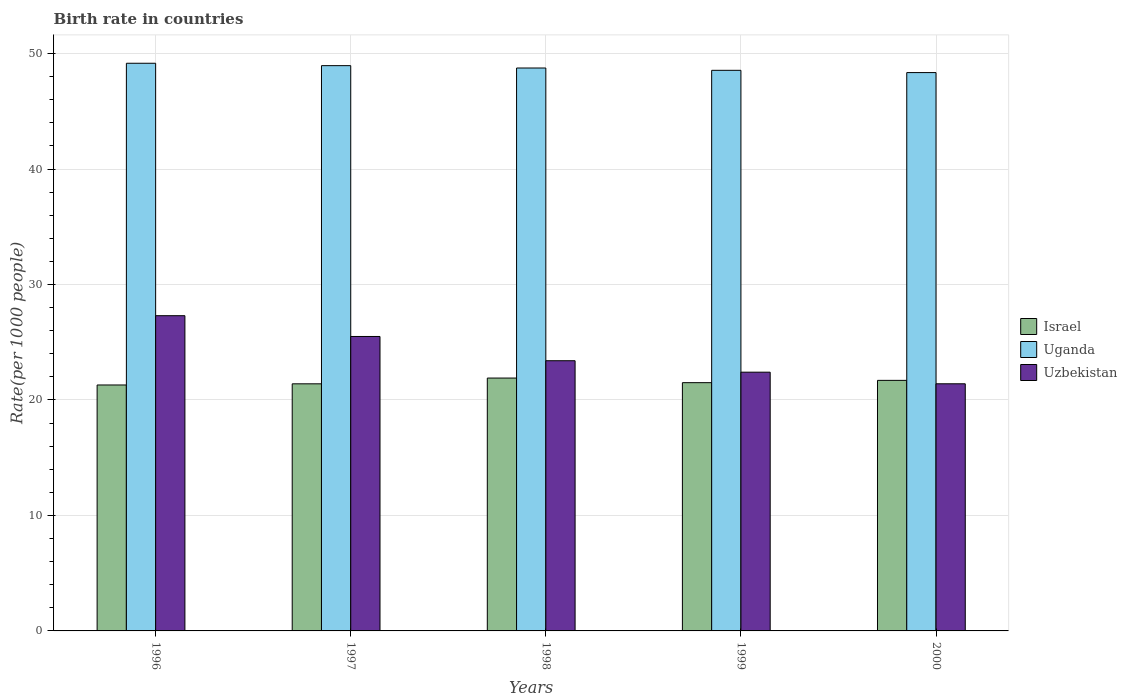How many groups of bars are there?
Provide a succinct answer. 5. Are the number of bars per tick equal to the number of legend labels?
Give a very brief answer. Yes. In how many cases, is the number of bars for a given year not equal to the number of legend labels?
Keep it short and to the point. 0. What is the birth rate in Uganda in 1998?
Keep it short and to the point. 48.75. Across all years, what is the maximum birth rate in Uzbekistan?
Make the answer very short. 27.3. Across all years, what is the minimum birth rate in Uganda?
Keep it short and to the point. 48.35. In which year was the birth rate in Israel minimum?
Make the answer very short. 1996. What is the total birth rate in Uganda in the graph?
Give a very brief answer. 243.78. What is the difference between the birth rate in Uzbekistan in 1997 and that in 2000?
Your answer should be compact. 4.1. What is the difference between the birth rate in Israel in 2000 and the birth rate in Uganda in 1997?
Make the answer very short. -27.26. What is the average birth rate in Uganda per year?
Give a very brief answer. 48.76. In the year 1997, what is the difference between the birth rate in Uganda and birth rate in Israel?
Keep it short and to the point. 27.56. In how many years, is the birth rate in Uganda greater than 12?
Offer a very short reply. 5. What is the ratio of the birth rate in Uganda in 1996 to that in 1997?
Give a very brief answer. 1. Is the birth rate in Uganda in 1998 less than that in 2000?
Give a very brief answer. No. Is the difference between the birth rate in Uganda in 1996 and 1998 greater than the difference between the birth rate in Israel in 1996 and 1998?
Offer a very short reply. Yes. What is the difference between the highest and the second highest birth rate in Israel?
Make the answer very short. 0.2. What is the difference between the highest and the lowest birth rate in Uganda?
Keep it short and to the point. 0.81. What does the 3rd bar from the left in 1996 represents?
Provide a succinct answer. Uzbekistan. What does the 1st bar from the right in 1996 represents?
Your response must be concise. Uzbekistan. Is it the case that in every year, the sum of the birth rate in Israel and birth rate in Uganda is greater than the birth rate in Uzbekistan?
Offer a very short reply. Yes. How many years are there in the graph?
Keep it short and to the point. 5. Does the graph contain any zero values?
Ensure brevity in your answer.  No. Does the graph contain grids?
Your answer should be compact. Yes. How are the legend labels stacked?
Keep it short and to the point. Vertical. What is the title of the graph?
Provide a short and direct response. Birth rate in countries. Does "Italy" appear as one of the legend labels in the graph?
Ensure brevity in your answer.  No. What is the label or title of the X-axis?
Make the answer very short. Years. What is the label or title of the Y-axis?
Your answer should be compact. Rate(per 1000 people). What is the Rate(per 1000 people) of Israel in 1996?
Offer a very short reply. 21.3. What is the Rate(per 1000 people) in Uganda in 1996?
Your response must be concise. 49.16. What is the Rate(per 1000 people) of Uzbekistan in 1996?
Offer a very short reply. 27.3. What is the Rate(per 1000 people) in Israel in 1997?
Give a very brief answer. 21.4. What is the Rate(per 1000 people) in Uganda in 1997?
Ensure brevity in your answer.  48.96. What is the Rate(per 1000 people) in Uzbekistan in 1997?
Provide a short and direct response. 25.5. What is the Rate(per 1000 people) of Israel in 1998?
Provide a succinct answer. 21.9. What is the Rate(per 1000 people) in Uganda in 1998?
Give a very brief answer. 48.75. What is the Rate(per 1000 people) in Uzbekistan in 1998?
Give a very brief answer. 23.4. What is the Rate(per 1000 people) of Israel in 1999?
Offer a terse response. 21.5. What is the Rate(per 1000 people) of Uganda in 1999?
Your answer should be compact. 48.55. What is the Rate(per 1000 people) of Uzbekistan in 1999?
Offer a terse response. 22.41. What is the Rate(per 1000 people) in Israel in 2000?
Offer a terse response. 21.7. What is the Rate(per 1000 people) in Uganda in 2000?
Your response must be concise. 48.35. What is the Rate(per 1000 people) in Uzbekistan in 2000?
Keep it short and to the point. 21.4. Across all years, what is the maximum Rate(per 1000 people) of Israel?
Keep it short and to the point. 21.9. Across all years, what is the maximum Rate(per 1000 people) of Uganda?
Give a very brief answer. 49.16. Across all years, what is the maximum Rate(per 1000 people) in Uzbekistan?
Ensure brevity in your answer.  27.3. Across all years, what is the minimum Rate(per 1000 people) of Israel?
Provide a short and direct response. 21.3. Across all years, what is the minimum Rate(per 1000 people) in Uganda?
Your answer should be compact. 48.35. Across all years, what is the minimum Rate(per 1000 people) in Uzbekistan?
Offer a terse response. 21.4. What is the total Rate(per 1000 people) of Israel in the graph?
Offer a very short reply. 107.8. What is the total Rate(per 1000 people) in Uganda in the graph?
Offer a terse response. 243.78. What is the total Rate(per 1000 people) of Uzbekistan in the graph?
Your response must be concise. 120.01. What is the difference between the Rate(per 1000 people) of Israel in 1996 and that in 1997?
Provide a succinct answer. -0.1. What is the difference between the Rate(per 1000 people) of Uganda in 1996 and that in 1997?
Make the answer very short. 0.21. What is the difference between the Rate(per 1000 people) in Uganda in 1996 and that in 1998?
Make the answer very short. 0.41. What is the difference between the Rate(per 1000 people) of Uzbekistan in 1996 and that in 1998?
Your answer should be compact. 3.9. What is the difference between the Rate(per 1000 people) of Uganda in 1996 and that in 1999?
Give a very brief answer. 0.61. What is the difference between the Rate(per 1000 people) in Uzbekistan in 1996 and that in 1999?
Keep it short and to the point. 4.89. What is the difference between the Rate(per 1000 people) in Israel in 1996 and that in 2000?
Make the answer very short. -0.4. What is the difference between the Rate(per 1000 people) of Uganda in 1996 and that in 2000?
Offer a very short reply. 0.81. What is the difference between the Rate(per 1000 people) of Uzbekistan in 1996 and that in 2000?
Keep it short and to the point. 5.9. What is the difference between the Rate(per 1000 people) in Israel in 1997 and that in 1998?
Keep it short and to the point. -0.5. What is the difference between the Rate(per 1000 people) in Uganda in 1997 and that in 1998?
Give a very brief answer. 0.2. What is the difference between the Rate(per 1000 people) in Israel in 1997 and that in 1999?
Provide a succinct answer. -0.1. What is the difference between the Rate(per 1000 people) in Uganda in 1997 and that in 1999?
Provide a succinct answer. 0.4. What is the difference between the Rate(per 1000 people) in Uzbekistan in 1997 and that in 1999?
Make the answer very short. 3.09. What is the difference between the Rate(per 1000 people) in Uganda in 1997 and that in 2000?
Give a very brief answer. 0.6. What is the difference between the Rate(per 1000 people) in Uzbekistan in 1997 and that in 2000?
Give a very brief answer. 4.1. What is the difference between the Rate(per 1000 people) in Israel in 1998 and that in 1999?
Your answer should be very brief. 0.4. What is the difference between the Rate(per 1000 people) in Uganda in 1998 and that in 1999?
Give a very brief answer. 0.2. What is the difference between the Rate(per 1000 people) of Israel in 1998 and that in 2000?
Offer a terse response. 0.2. What is the difference between the Rate(per 1000 people) in Uganda in 1998 and that in 2000?
Your answer should be very brief. 0.4. What is the difference between the Rate(per 1000 people) in Uzbekistan in 1998 and that in 2000?
Your answer should be very brief. 2. What is the difference between the Rate(per 1000 people) of Uganda in 1999 and that in 2000?
Your answer should be compact. 0.2. What is the difference between the Rate(per 1000 people) of Israel in 1996 and the Rate(per 1000 people) of Uganda in 1997?
Provide a short and direct response. -27.66. What is the difference between the Rate(per 1000 people) in Uganda in 1996 and the Rate(per 1000 people) in Uzbekistan in 1997?
Keep it short and to the point. 23.66. What is the difference between the Rate(per 1000 people) in Israel in 1996 and the Rate(per 1000 people) in Uganda in 1998?
Provide a succinct answer. -27.45. What is the difference between the Rate(per 1000 people) of Israel in 1996 and the Rate(per 1000 people) of Uzbekistan in 1998?
Your answer should be very brief. -2.1. What is the difference between the Rate(per 1000 people) in Uganda in 1996 and the Rate(per 1000 people) in Uzbekistan in 1998?
Make the answer very short. 25.76. What is the difference between the Rate(per 1000 people) of Israel in 1996 and the Rate(per 1000 people) of Uganda in 1999?
Offer a terse response. -27.25. What is the difference between the Rate(per 1000 people) in Israel in 1996 and the Rate(per 1000 people) in Uzbekistan in 1999?
Keep it short and to the point. -1.11. What is the difference between the Rate(per 1000 people) of Uganda in 1996 and the Rate(per 1000 people) of Uzbekistan in 1999?
Offer a terse response. 26.75. What is the difference between the Rate(per 1000 people) of Israel in 1996 and the Rate(per 1000 people) of Uganda in 2000?
Your answer should be very brief. -27.05. What is the difference between the Rate(per 1000 people) of Israel in 1996 and the Rate(per 1000 people) of Uzbekistan in 2000?
Your answer should be very brief. -0.1. What is the difference between the Rate(per 1000 people) of Uganda in 1996 and the Rate(per 1000 people) of Uzbekistan in 2000?
Provide a short and direct response. 27.76. What is the difference between the Rate(per 1000 people) of Israel in 1997 and the Rate(per 1000 people) of Uganda in 1998?
Your answer should be compact. -27.35. What is the difference between the Rate(per 1000 people) in Israel in 1997 and the Rate(per 1000 people) in Uzbekistan in 1998?
Give a very brief answer. -2. What is the difference between the Rate(per 1000 people) in Uganda in 1997 and the Rate(per 1000 people) in Uzbekistan in 1998?
Give a very brief answer. 25.56. What is the difference between the Rate(per 1000 people) in Israel in 1997 and the Rate(per 1000 people) in Uganda in 1999?
Make the answer very short. -27.15. What is the difference between the Rate(per 1000 people) of Israel in 1997 and the Rate(per 1000 people) of Uzbekistan in 1999?
Offer a very short reply. -1.01. What is the difference between the Rate(per 1000 people) of Uganda in 1997 and the Rate(per 1000 people) of Uzbekistan in 1999?
Give a very brief answer. 26.55. What is the difference between the Rate(per 1000 people) in Israel in 1997 and the Rate(per 1000 people) in Uganda in 2000?
Offer a terse response. -26.95. What is the difference between the Rate(per 1000 people) of Israel in 1997 and the Rate(per 1000 people) of Uzbekistan in 2000?
Give a very brief answer. -0. What is the difference between the Rate(per 1000 people) of Uganda in 1997 and the Rate(per 1000 people) of Uzbekistan in 2000?
Give a very brief answer. 27.55. What is the difference between the Rate(per 1000 people) in Israel in 1998 and the Rate(per 1000 people) in Uganda in 1999?
Your answer should be very brief. -26.65. What is the difference between the Rate(per 1000 people) in Israel in 1998 and the Rate(per 1000 people) in Uzbekistan in 1999?
Your answer should be compact. -0.51. What is the difference between the Rate(per 1000 people) in Uganda in 1998 and the Rate(per 1000 people) in Uzbekistan in 1999?
Give a very brief answer. 26.34. What is the difference between the Rate(per 1000 people) in Israel in 1998 and the Rate(per 1000 people) in Uganda in 2000?
Your answer should be compact. -26.45. What is the difference between the Rate(per 1000 people) in Israel in 1998 and the Rate(per 1000 people) in Uzbekistan in 2000?
Keep it short and to the point. 0.5. What is the difference between the Rate(per 1000 people) of Uganda in 1998 and the Rate(per 1000 people) of Uzbekistan in 2000?
Ensure brevity in your answer.  27.35. What is the difference between the Rate(per 1000 people) in Israel in 1999 and the Rate(per 1000 people) in Uganda in 2000?
Provide a succinct answer. -26.86. What is the difference between the Rate(per 1000 people) of Israel in 1999 and the Rate(per 1000 people) of Uzbekistan in 2000?
Offer a terse response. 0.1. What is the difference between the Rate(per 1000 people) of Uganda in 1999 and the Rate(per 1000 people) of Uzbekistan in 2000?
Make the answer very short. 27.15. What is the average Rate(per 1000 people) of Israel per year?
Provide a succinct answer. 21.56. What is the average Rate(per 1000 people) of Uganda per year?
Give a very brief answer. 48.76. What is the average Rate(per 1000 people) of Uzbekistan per year?
Provide a short and direct response. 24. In the year 1996, what is the difference between the Rate(per 1000 people) of Israel and Rate(per 1000 people) of Uganda?
Keep it short and to the point. -27.86. In the year 1996, what is the difference between the Rate(per 1000 people) of Uganda and Rate(per 1000 people) of Uzbekistan?
Ensure brevity in your answer.  21.86. In the year 1997, what is the difference between the Rate(per 1000 people) of Israel and Rate(per 1000 people) of Uganda?
Offer a very short reply. -27.56. In the year 1997, what is the difference between the Rate(per 1000 people) in Israel and Rate(per 1000 people) in Uzbekistan?
Ensure brevity in your answer.  -4.1. In the year 1997, what is the difference between the Rate(per 1000 people) of Uganda and Rate(per 1000 people) of Uzbekistan?
Your answer should be very brief. 23.46. In the year 1998, what is the difference between the Rate(per 1000 people) in Israel and Rate(per 1000 people) in Uganda?
Offer a very short reply. -26.85. In the year 1998, what is the difference between the Rate(per 1000 people) in Israel and Rate(per 1000 people) in Uzbekistan?
Give a very brief answer. -1.5. In the year 1998, what is the difference between the Rate(per 1000 people) in Uganda and Rate(per 1000 people) in Uzbekistan?
Your answer should be very brief. 25.35. In the year 1999, what is the difference between the Rate(per 1000 people) in Israel and Rate(per 1000 people) in Uganda?
Give a very brief answer. -27.05. In the year 1999, what is the difference between the Rate(per 1000 people) in Israel and Rate(per 1000 people) in Uzbekistan?
Your response must be concise. -0.91. In the year 1999, what is the difference between the Rate(per 1000 people) of Uganda and Rate(per 1000 people) of Uzbekistan?
Provide a succinct answer. 26.14. In the year 2000, what is the difference between the Rate(per 1000 people) in Israel and Rate(per 1000 people) in Uganda?
Keep it short and to the point. -26.66. In the year 2000, what is the difference between the Rate(per 1000 people) in Israel and Rate(per 1000 people) in Uzbekistan?
Make the answer very short. 0.3. In the year 2000, what is the difference between the Rate(per 1000 people) in Uganda and Rate(per 1000 people) in Uzbekistan?
Your response must be concise. 26.95. What is the ratio of the Rate(per 1000 people) of Uganda in 1996 to that in 1997?
Provide a short and direct response. 1. What is the ratio of the Rate(per 1000 people) in Uzbekistan in 1996 to that in 1997?
Provide a succinct answer. 1.07. What is the ratio of the Rate(per 1000 people) of Israel in 1996 to that in 1998?
Ensure brevity in your answer.  0.97. What is the ratio of the Rate(per 1000 people) in Uganda in 1996 to that in 1998?
Your answer should be compact. 1.01. What is the ratio of the Rate(per 1000 people) in Uzbekistan in 1996 to that in 1998?
Ensure brevity in your answer.  1.17. What is the ratio of the Rate(per 1000 people) in Uganda in 1996 to that in 1999?
Offer a very short reply. 1.01. What is the ratio of the Rate(per 1000 people) in Uzbekistan in 1996 to that in 1999?
Offer a terse response. 1.22. What is the ratio of the Rate(per 1000 people) in Israel in 1996 to that in 2000?
Make the answer very short. 0.98. What is the ratio of the Rate(per 1000 people) of Uganda in 1996 to that in 2000?
Your answer should be compact. 1.02. What is the ratio of the Rate(per 1000 people) of Uzbekistan in 1996 to that in 2000?
Give a very brief answer. 1.28. What is the ratio of the Rate(per 1000 people) of Israel in 1997 to that in 1998?
Offer a very short reply. 0.98. What is the ratio of the Rate(per 1000 people) in Uzbekistan in 1997 to that in 1998?
Your response must be concise. 1.09. What is the ratio of the Rate(per 1000 people) in Israel in 1997 to that in 1999?
Your answer should be compact. 1. What is the ratio of the Rate(per 1000 people) in Uganda in 1997 to that in 1999?
Give a very brief answer. 1.01. What is the ratio of the Rate(per 1000 people) in Uzbekistan in 1997 to that in 1999?
Ensure brevity in your answer.  1.14. What is the ratio of the Rate(per 1000 people) of Israel in 1997 to that in 2000?
Provide a succinct answer. 0.99. What is the ratio of the Rate(per 1000 people) of Uganda in 1997 to that in 2000?
Provide a short and direct response. 1.01. What is the ratio of the Rate(per 1000 people) in Uzbekistan in 1997 to that in 2000?
Make the answer very short. 1.19. What is the ratio of the Rate(per 1000 people) of Israel in 1998 to that in 1999?
Offer a very short reply. 1.02. What is the ratio of the Rate(per 1000 people) of Uzbekistan in 1998 to that in 1999?
Your answer should be very brief. 1.04. What is the ratio of the Rate(per 1000 people) in Israel in 1998 to that in 2000?
Your answer should be very brief. 1.01. What is the ratio of the Rate(per 1000 people) in Uganda in 1998 to that in 2000?
Offer a very short reply. 1.01. What is the ratio of the Rate(per 1000 people) in Uzbekistan in 1998 to that in 2000?
Provide a short and direct response. 1.09. What is the ratio of the Rate(per 1000 people) in Israel in 1999 to that in 2000?
Your response must be concise. 0.99. What is the ratio of the Rate(per 1000 people) in Uzbekistan in 1999 to that in 2000?
Your response must be concise. 1.05. What is the difference between the highest and the second highest Rate(per 1000 people) of Uganda?
Ensure brevity in your answer.  0.21. What is the difference between the highest and the lowest Rate(per 1000 people) of Israel?
Ensure brevity in your answer.  0.6. What is the difference between the highest and the lowest Rate(per 1000 people) of Uganda?
Your response must be concise. 0.81. What is the difference between the highest and the lowest Rate(per 1000 people) of Uzbekistan?
Your response must be concise. 5.9. 